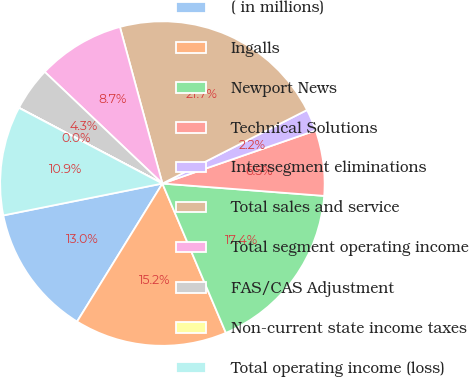Convert chart. <chart><loc_0><loc_0><loc_500><loc_500><pie_chart><fcel>( in millions)<fcel>Ingalls<fcel>Newport News<fcel>Technical Solutions<fcel>Intersegment eliminations<fcel>Total sales and service<fcel>Total segment operating income<fcel>FAS/CAS Adjustment<fcel>Non-current state income taxes<fcel>Total operating income (loss)<nl><fcel>13.04%<fcel>15.21%<fcel>17.39%<fcel>6.52%<fcel>2.18%<fcel>21.73%<fcel>8.7%<fcel>4.35%<fcel>0.01%<fcel>10.87%<nl></chart> 